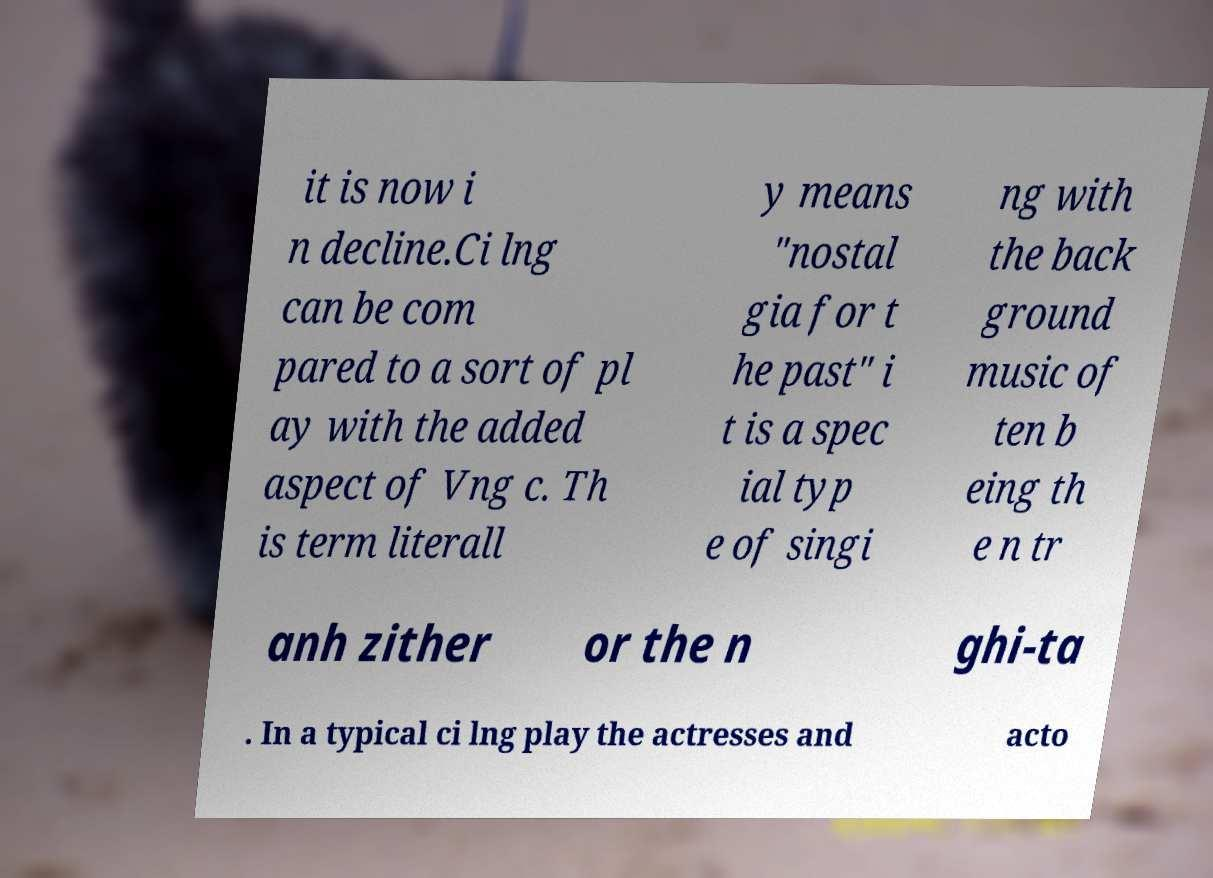I need the written content from this picture converted into text. Can you do that? it is now i n decline.Ci lng can be com pared to a sort of pl ay with the added aspect of Vng c. Th is term literall y means "nostal gia for t he past" i t is a spec ial typ e of singi ng with the back ground music of ten b eing th e n tr anh zither or the n ghi-ta . In a typical ci lng play the actresses and acto 